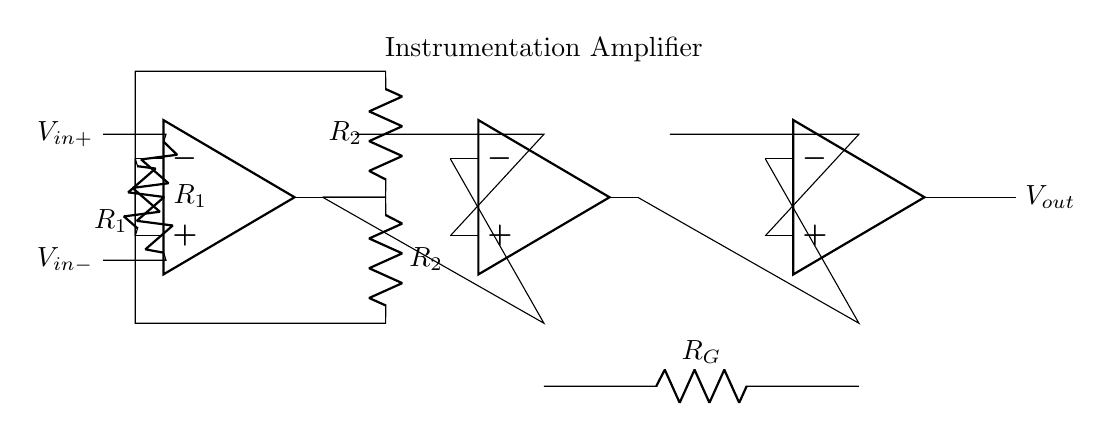What is the type of amplifier used in this circuit? The circuit diagram shows an instrumentation amplifier, which is characterized by its use of multiple operational amplifiers to achieve high input impedance and precise differential signal amplification.
Answer: instrumentation amplifier What are the values of the resistors connected to the non-inverting inputs? The resistors connected to the non-inverting inputs are both labeled as R1, indicating they have the same resistance value, contributing to the balanced operation of the amplifier.
Answer: R1 How many operational amplifiers are present in this circuit? The circuit contains three operational amplifiers, as indicated by the three distinct op-amp symbols in the diagram.
Answer: three What is the purpose of the feedback resistors in this configuration? The feedback resistors, labeled R2, are essential for setting the gain of the op-amps in the instrumentation amplifier, allowing for controlled amplification of the differential input signal.
Answer: gain control What is the output voltage of the circuit labeled as? The output voltage of the circuit is labeled as Vout, which represents the amplified output signal generated by the instrumentation amplifier based on the input differential voltage.
Answer: Vout What is connected to the inverting inputs of the first two operational amplifiers? The inverting inputs of the first two operational amplifiers are connected through resistors, forming a feedback loop that helps balance the amplifier's response to differential signals.
Answer: R2 What do the resistors labeled R_G represent in this circuit? The resistor labeled R_G is designated as the gain resistor, which is crucial in determining the overall gain of the instrumentation amplifier by affecting how the output voltage relates to the input voltage difference.
Answer: gain resistor 